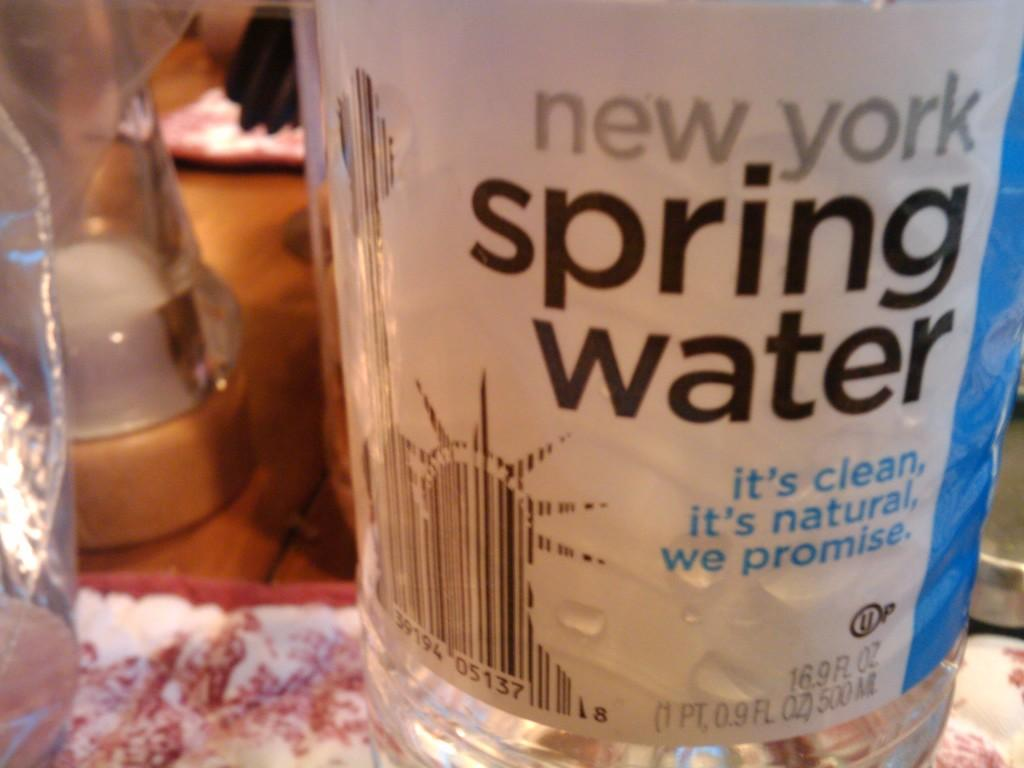What object can be seen in the image that is used for holding liquids? There is a water bottle in the image that is used for holding liquids. Where is the water bottle located in the image? The water bottle is placed on a table in the image. What is the color of the table? The table is brown in color. What can be seen on the cover of the water bottle? There is text on the cover of the water bottle. What musical instrument is being played in the image? There is no musical instrument being played in the image; it only features a water bottle on a table. 